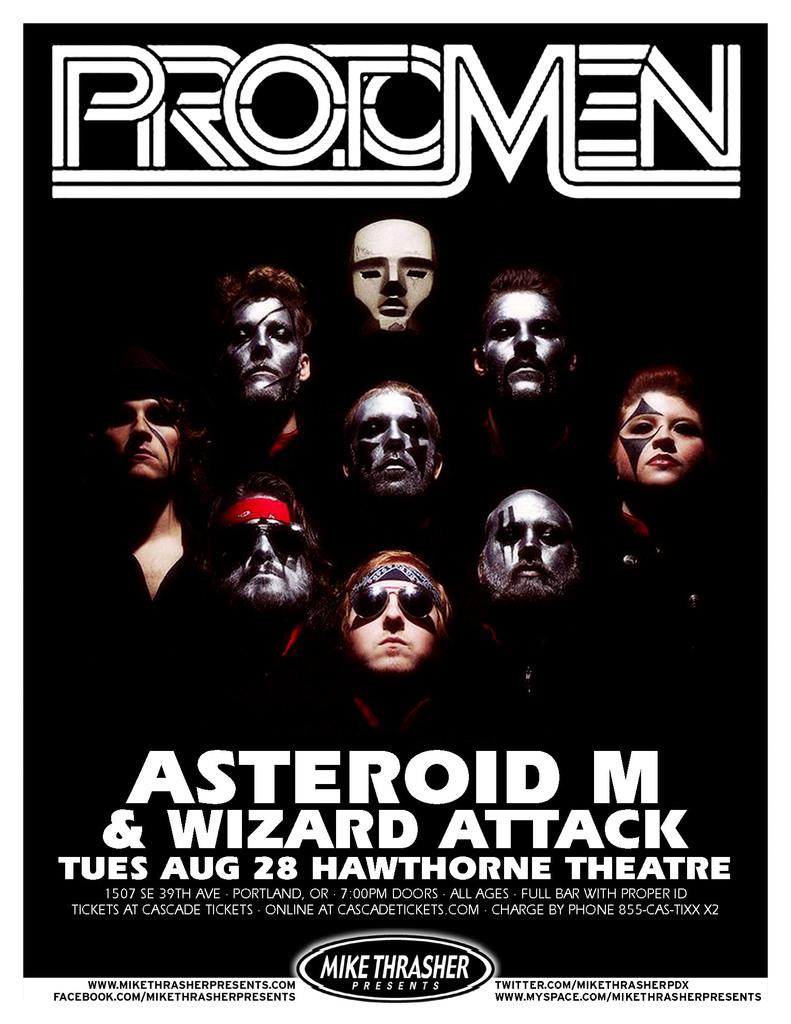What day of the week is the concert?
Provide a short and direct response. Tuesday. 